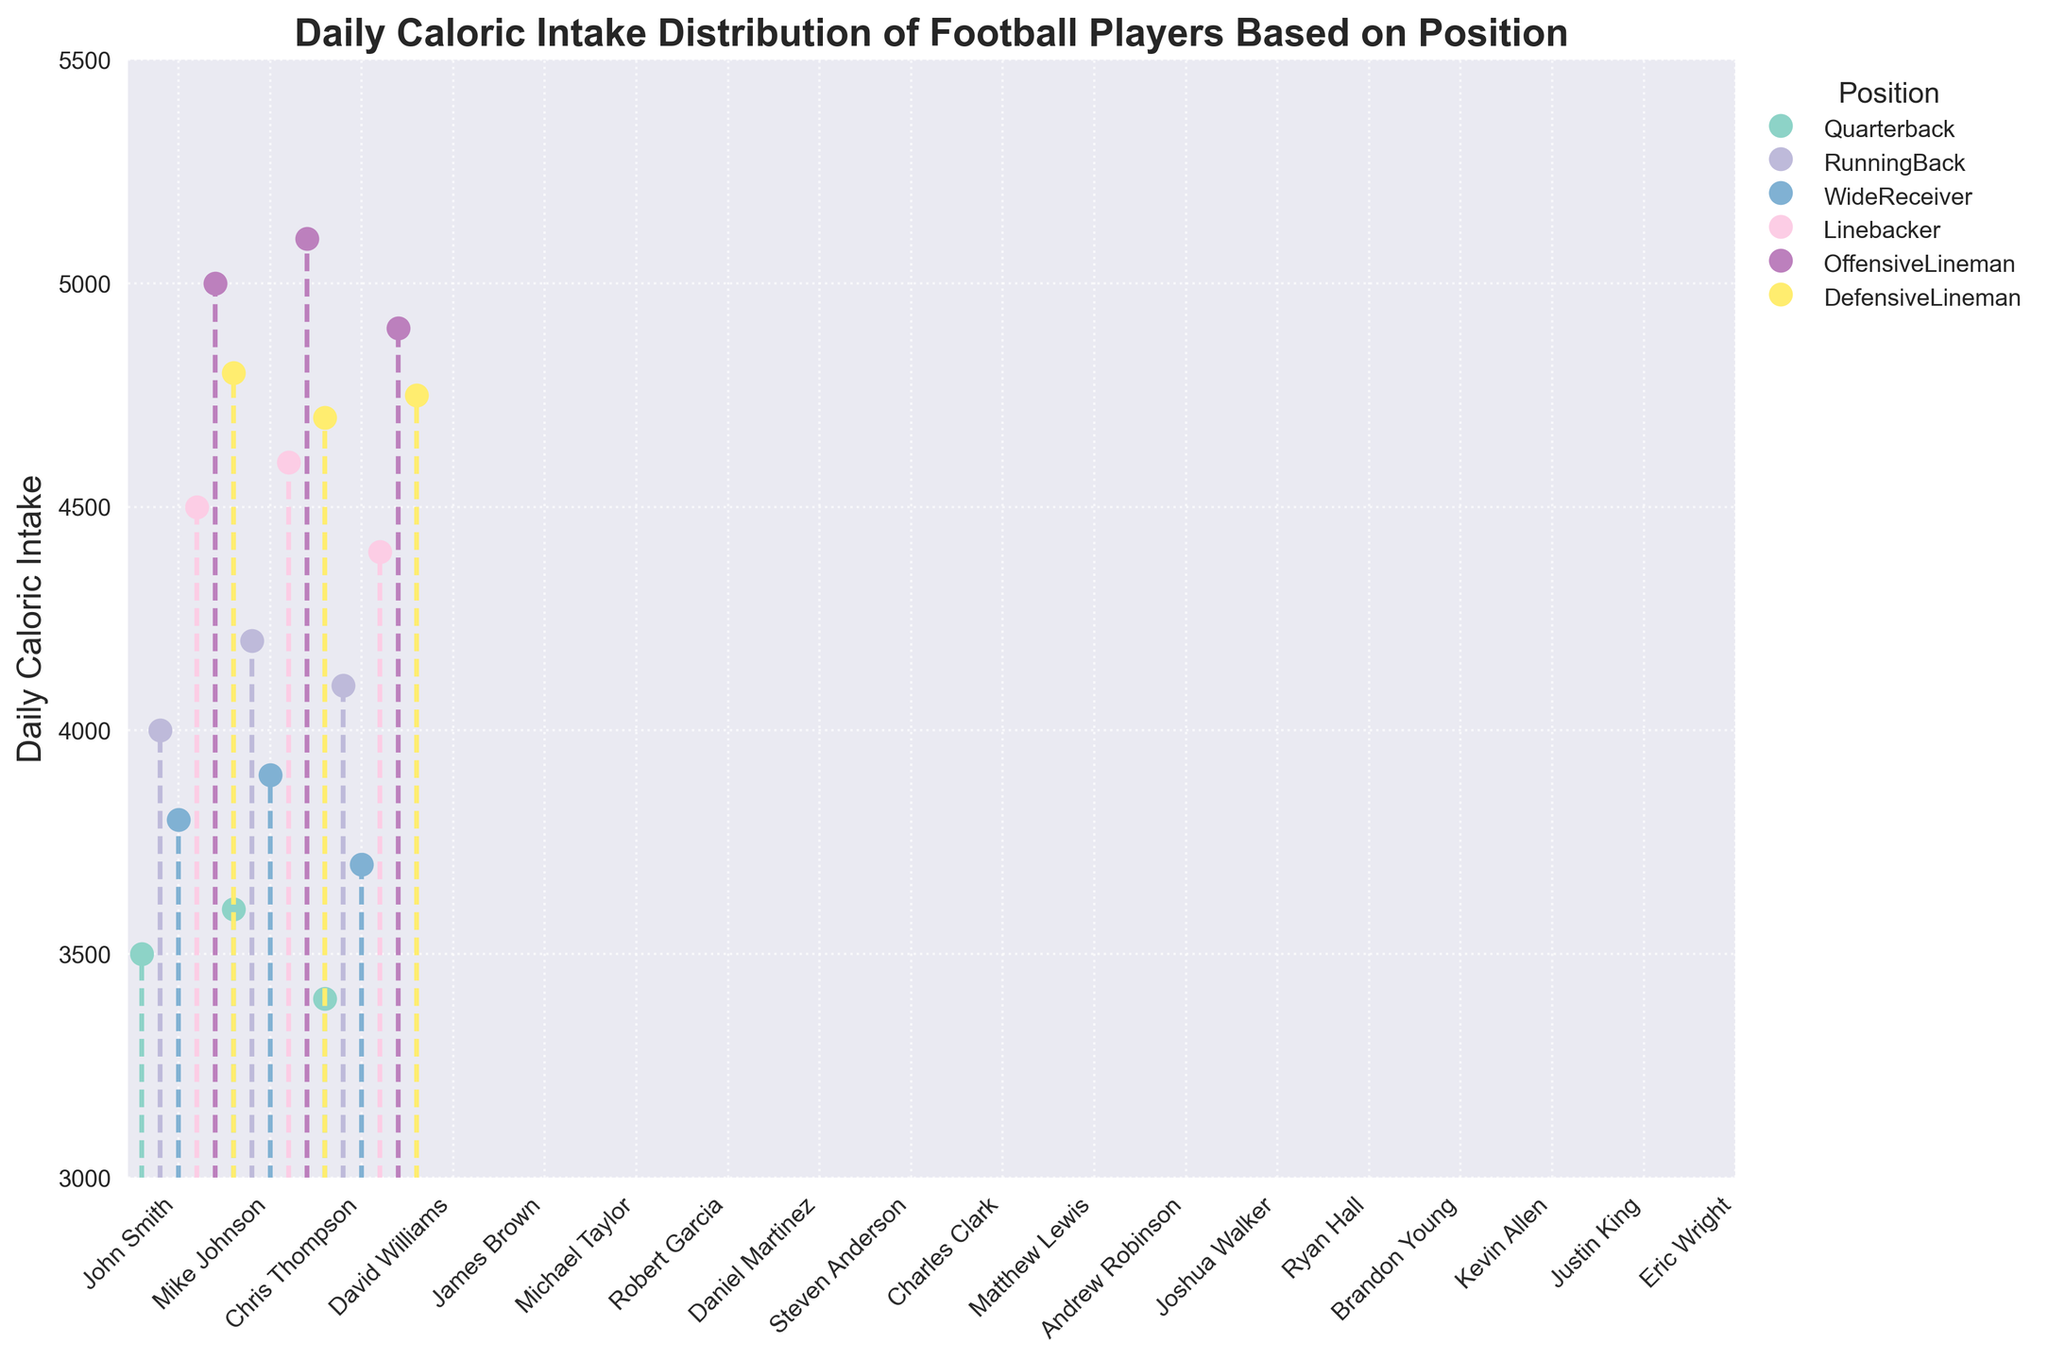What is the title of the plot? The title is usually located at the top of the figure. It helps to quickly understand what the plot is about.
Answer: Daily Caloric Intake Distribution of Football Players Based on Position How many categories of positions are represented in the plot? We can determine the number of position categories by looking at the legend that lists the various positions.
Answer: 6 Which position has the player with the highest daily caloric intake? By analyzing the position of the highest marker in the plot, we can determine which position it belongs to.
Answer: OffensiveLineman What is the range of daily caloric intake among the linebackers? We need to identify the highest and lowest values in the linebackers' data points and find the difference between them.
Answer: 4600 - 4400 How does the daily caloric intake of quarterbacks compare to that of running backs? Compare the caloric intake figures for the quarterbacks and running backs by examining their respective markers in the plot.
Answer: Running backs have higher daily caloric intake on average than quarterbacks What is the average daily caloric intake of wide receivers? First, identify the daily caloric intake values for the wide receivers, then calculate their average. (3800 + 3900 + 3700)/3 = 3800
Answer: 3800 Are there any positions that have an overlapping range of daily caloric intake? Look at the different stems and markers to see if the caloric intake values for any positions overlap with each other.
Answer: Yes, DefensiveLineman and OffensiveLineman overlap around the 4800 mark Which player's caloric intake differs the most from his position’s average intake? Calculate the average intake for each position, then find the player who has the largest difference from his position’s average. (4500 + 4600 + 4400)/3 = 4500; Matthew Lewis' intake = 4600; Difference = 100
Answer: Matthew Lewis How many players have a daily caloric intake of less than 4000? Count the number of markers that fall below the 4000-caloric intake level while reviewing the plot.
Answer: 3 